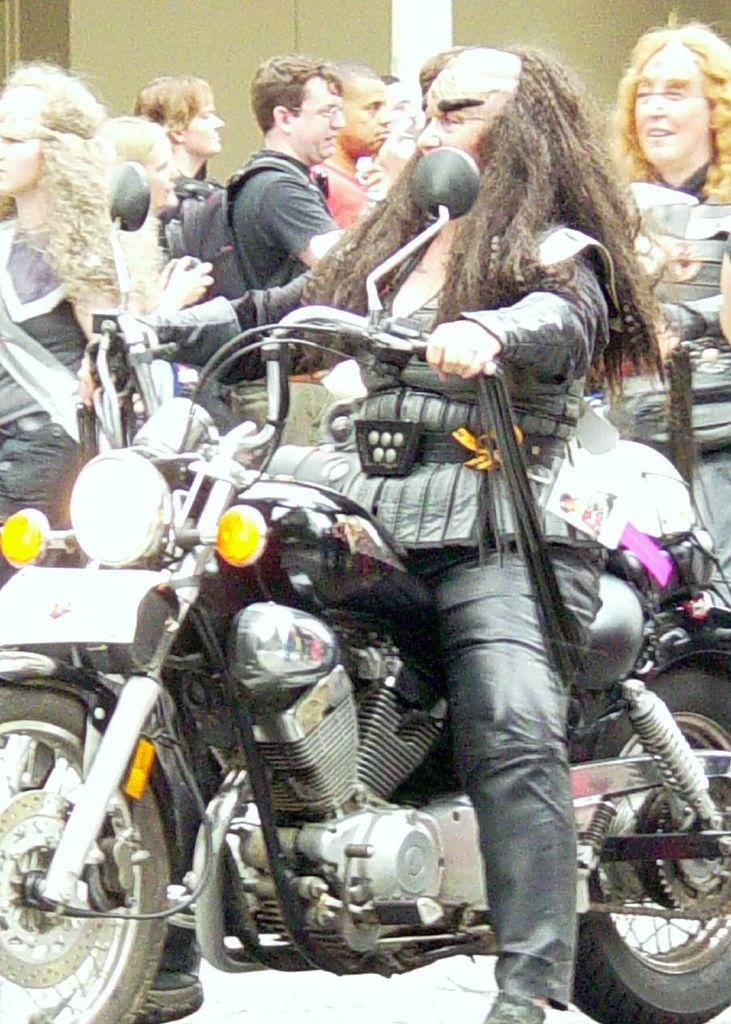Who is the main subject in the image? There is a man in the image. What is the man doing in the image? The man is on a bike. Can you describe the background of the image? There are people in the background of the image. What type of sticks can be seen in the man's attempt to fix the sink in the image? There is no sink or attempt to fix it in the image; the man is simply riding a bike. 